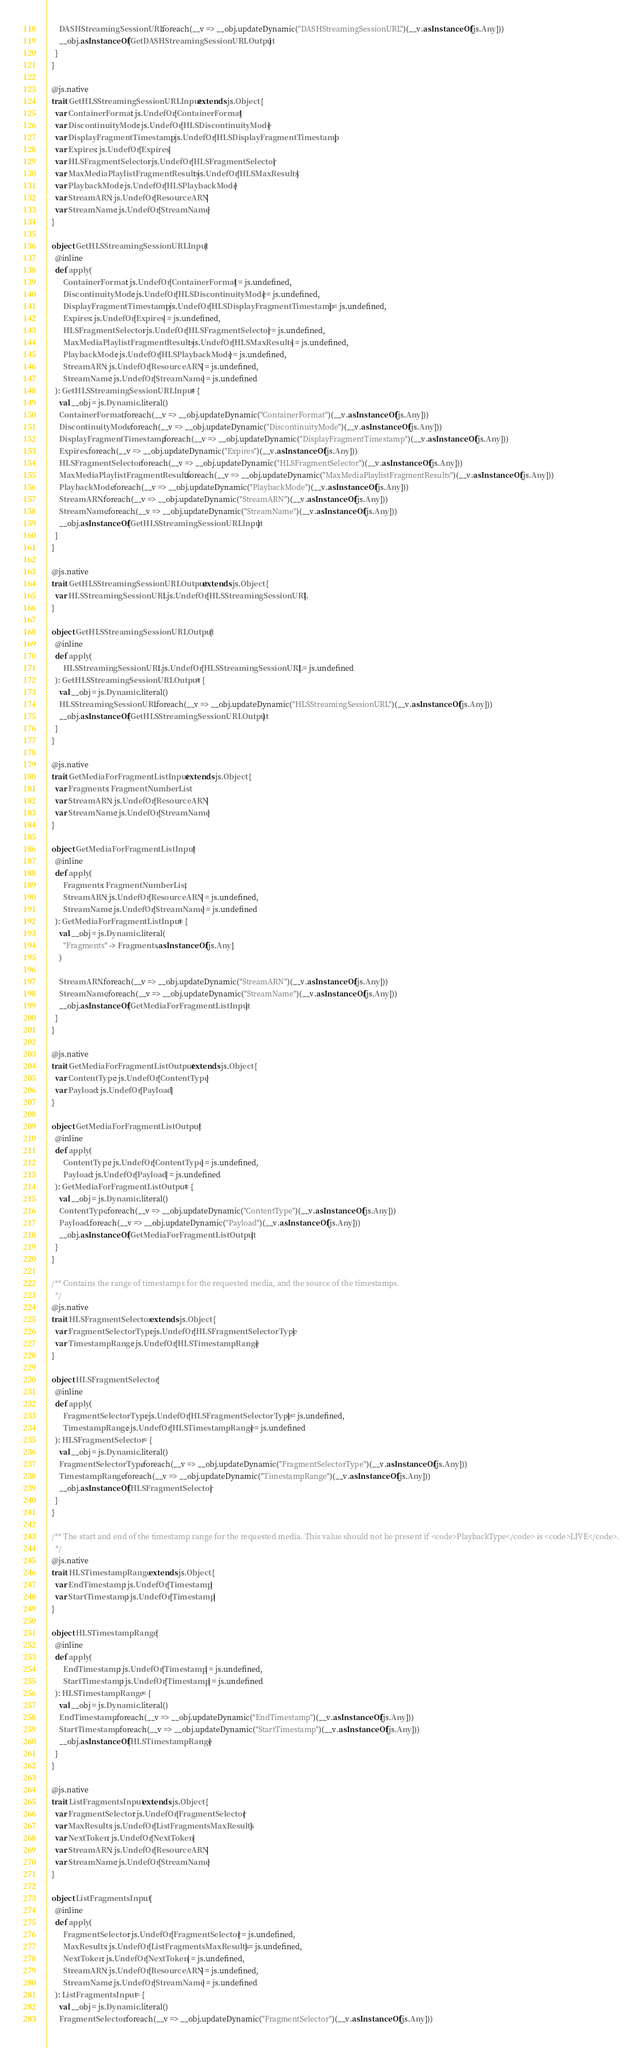Convert code to text. <code><loc_0><loc_0><loc_500><loc_500><_Scala_>      DASHStreamingSessionURL.foreach(__v => __obj.updateDynamic("DASHStreamingSessionURL")(__v.asInstanceOf[js.Any]))
      __obj.asInstanceOf[GetDASHStreamingSessionURLOutput]
    }
  }

  @js.native
  trait GetHLSStreamingSessionURLInput extends js.Object {
    var ContainerFormat: js.UndefOr[ContainerFormat]
    var DiscontinuityMode: js.UndefOr[HLSDiscontinuityMode]
    var DisplayFragmentTimestamp: js.UndefOr[HLSDisplayFragmentTimestamp]
    var Expires: js.UndefOr[Expires]
    var HLSFragmentSelector: js.UndefOr[HLSFragmentSelector]
    var MaxMediaPlaylistFragmentResults: js.UndefOr[HLSMaxResults]
    var PlaybackMode: js.UndefOr[HLSPlaybackMode]
    var StreamARN: js.UndefOr[ResourceARN]
    var StreamName: js.UndefOr[StreamName]
  }

  object GetHLSStreamingSessionURLInput {
    @inline
    def apply(
        ContainerFormat: js.UndefOr[ContainerFormat] = js.undefined,
        DiscontinuityMode: js.UndefOr[HLSDiscontinuityMode] = js.undefined,
        DisplayFragmentTimestamp: js.UndefOr[HLSDisplayFragmentTimestamp] = js.undefined,
        Expires: js.UndefOr[Expires] = js.undefined,
        HLSFragmentSelector: js.UndefOr[HLSFragmentSelector] = js.undefined,
        MaxMediaPlaylistFragmentResults: js.UndefOr[HLSMaxResults] = js.undefined,
        PlaybackMode: js.UndefOr[HLSPlaybackMode] = js.undefined,
        StreamARN: js.UndefOr[ResourceARN] = js.undefined,
        StreamName: js.UndefOr[StreamName] = js.undefined
    ): GetHLSStreamingSessionURLInput = {
      val __obj = js.Dynamic.literal()
      ContainerFormat.foreach(__v => __obj.updateDynamic("ContainerFormat")(__v.asInstanceOf[js.Any]))
      DiscontinuityMode.foreach(__v => __obj.updateDynamic("DiscontinuityMode")(__v.asInstanceOf[js.Any]))
      DisplayFragmentTimestamp.foreach(__v => __obj.updateDynamic("DisplayFragmentTimestamp")(__v.asInstanceOf[js.Any]))
      Expires.foreach(__v => __obj.updateDynamic("Expires")(__v.asInstanceOf[js.Any]))
      HLSFragmentSelector.foreach(__v => __obj.updateDynamic("HLSFragmentSelector")(__v.asInstanceOf[js.Any]))
      MaxMediaPlaylistFragmentResults.foreach(__v => __obj.updateDynamic("MaxMediaPlaylistFragmentResults")(__v.asInstanceOf[js.Any]))
      PlaybackMode.foreach(__v => __obj.updateDynamic("PlaybackMode")(__v.asInstanceOf[js.Any]))
      StreamARN.foreach(__v => __obj.updateDynamic("StreamARN")(__v.asInstanceOf[js.Any]))
      StreamName.foreach(__v => __obj.updateDynamic("StreamName")(__v.asInstanceOf[js.Any]))
      __obj.asInstanceOf[GetHLSStreamingSessionURLInput]
    }
  }

  @js.native
  trait GetHLSStreamingSessionURLOutput extends js.Object {
    var HLSStreamingSessionURL: js.UndefOr[HLSStreamingSessionURL]
  }

  object GetHLSStreamingSessionURLOutput {
    @inline
    def apply(
        HLSStreamingSessionURL: js.UndefOr[HLSStreamingSessionURL] = js.undefined
    ): GetHLSStreamingSessionURLOutput = {
      val __obj = js.Dynamic.literal()
      HLSStreamingSessionURL.foreach(__v => __obj.updateDynamic("HLSStreamingSessionURL")(__v.asInstanceOf[js.Any]))
      __obj.asInstanceOf[GetHLSStreamingSessionURLOutput]
    }
  }

  @js.native
  trait GetMediaForFragmentListInput extends js.Object {
    var Fragments: FragmentNumberList
    var StreamARN: js.UndefOr[ResourceARN]
    var StreamName: js.UndefOr[StreamName]
  }

  object GetMediaForFragmentListInput {
    @inline
    def apply(
        Fragments: FragmentNumberList,
        StreamARN: js.UndefOr[ResourceARN] = js.undefined,
        StreamName: js.UndefOr[StreamName] = js.undefined
    ): GetMediaForFragmentListInput = {
      val __obj = js.Dynamic.literal(
        "Fragments" -> Fragments.asInstanceOf[js.Any]
      )

      StreamARN.foreach(__v => __obj.updateDynamic("StreamARN")(__v.asInstanceOf[js.Any]))
      StreamName.foreach(__v => __obj.updateDynamic("StreamName")(__v.asInstanceOf[js.Any]))
      __obj.asInstanceOf[GetMediaForFragmentListInput]
    }
  }

  @js.native
  trait GetMediaForFragmentListOutput extends js.Object {
    var ContentType: js.UndefOr[ContentType]
    var Payload: js.UndefOr[Payload]
  }

  object GetMediaForFragmentListOutput {
    @inline
    def apply(
        ContentType: js.UndefOr[ContentType] = js.undefined,
        Payload: js.UndefOr[Payload] = js.undefined
    ): GetMediaForFragmentListOutput = {
      val __obj = js.Dynamic.literal()
      ContentType.foreach(__v => __obj.updateDynamic("ContentType")(__v.asInstanceOf[js.Any]))
      Payload.foreach(__v => __obj.updateDynamic("Payload")(__v.asInstanceOf[js.Any]))
      __obj.asInstanceOf[GetMediaForFragmentListOutput]
    }
  }

  /** Contains the range of timestamps for the requested media, and the source of the timestamps.
    */
  @js.native
  trait HLSFragmentSelector extends js.Object {
    var FragmentSelectorType: js.UndefOr[HLSFragmentSelectorType]
    var TimestampRange: js.UndefOr[HLSTimestampRange]
  }

  object HLSFragmentSelector {
    @inline
    def apply(
        FragmentSelectorType: js.UndefOr[HLSFragmentSelectorType] = js.undefined,
        TimestampRange: js.UndefOr[HLSTimestampRange] = js.undefined
    ): HLSFragmentSelector = {
      val __obj = js.Dynamic.literal()
      FragmentSelectorType.foreach(__v => __obj.updateDynamic("FragmentSelectorType")(__v.asInstanceOf[js.Any]))
      TimestampRange.foreach(__v => __obj.updateDynamic("TimestampRange")(__v.asInstanceOf[js.Any]))
      __obj.asInstanceOf[HLSFragmentSelector]
    }
  }

  /** The start and end of the timestamp range for the requested media. This value should not be present if <code>PlaybackType</code> is <code>LIVE</code>.
    */
  @js.native
  trait HLSTimestampRange extends js.Object {
    var EndTimestamp: js.UndefOr[Timestamp]
    var StartTimestamp: js.UndefOr[Timestamp]
  }

  object HLSTimestampRange {
    @inline
    def apply(
        EndTimestamp: js.UndefOr[Timestamp] = js.undefined,
        StartTimestamp: js.UndefOr[Timestamp] = js.undefined
    ): HLSTimestampRange = {
      val __obj = js.Dynamic.literal()
      EndTimestamp.foreach(__v => __obj.updateDynamic("EndTimestamp")(__v.asInstanceOf[js.Any]))
      StartTimestamp.foreach(__v => __obj.updateDynamic("StartTimestamp")(__v.asInstanceOf[js.Any]))
      __obj.asInstanceOf[HLSTimestampRange]
    }
  }

  @js.native
  trait ListFragmentsInput extends js.Object {
    var FragmentSelector: js.UndefOr[FragmentSelector]
    var MaxResults: js.UndefOr[ListFragmentsMaxResults]
    var NextToken: js.UndefOr[NextToken]
    var StreamARN: js.UndefOr[ResourceARN]
    var StreamName: js.UndefOr[StreamName]
  }

  object ListFragmentsInput {
    @inline
    def apply(
        FragmentSelector: js.UndefOr[FragmentSelector] = js.undefined,
        MaxResults: js.UndefOr[ListFragmentsMaxResults] = js.undefined,
        NextToken: js.UndefOr[NextToken] = js.undefined,
        StreamARN: js.UndefOr[ResourceARN] = js.undefined,
        StreamName: js.UndefOr[StreamName] = js.undefined
    ): ListFragmentsInput = {
      val __obj = js.Dynamic.literal()
      FragmentSelector.foreach(__v => __obj.updateDynamic("FragmentSelector")(__v.asInstanceOf[js.Any]))</code> 